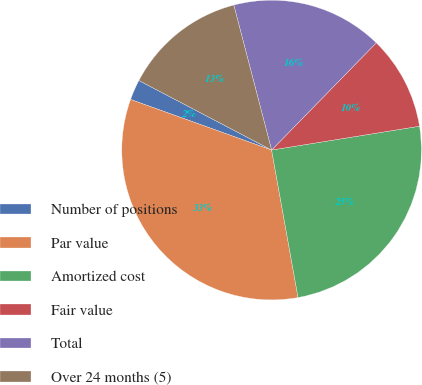Convert chart to OTSL. <chart><loc_0><loc_0><loc_500><loc_500><pie_chart><fcel>Number of positions<fcel>Par value<fcel>Amortized cost<fcel>Fair value<fcel>Total<fcel>Over 24 months (5)<nl><fcel>2.2%<fcel>33.31%<fcel>24.72%<fcel>10.15%<fcel>16.37%<fcel>13.26%<nl></chart> 